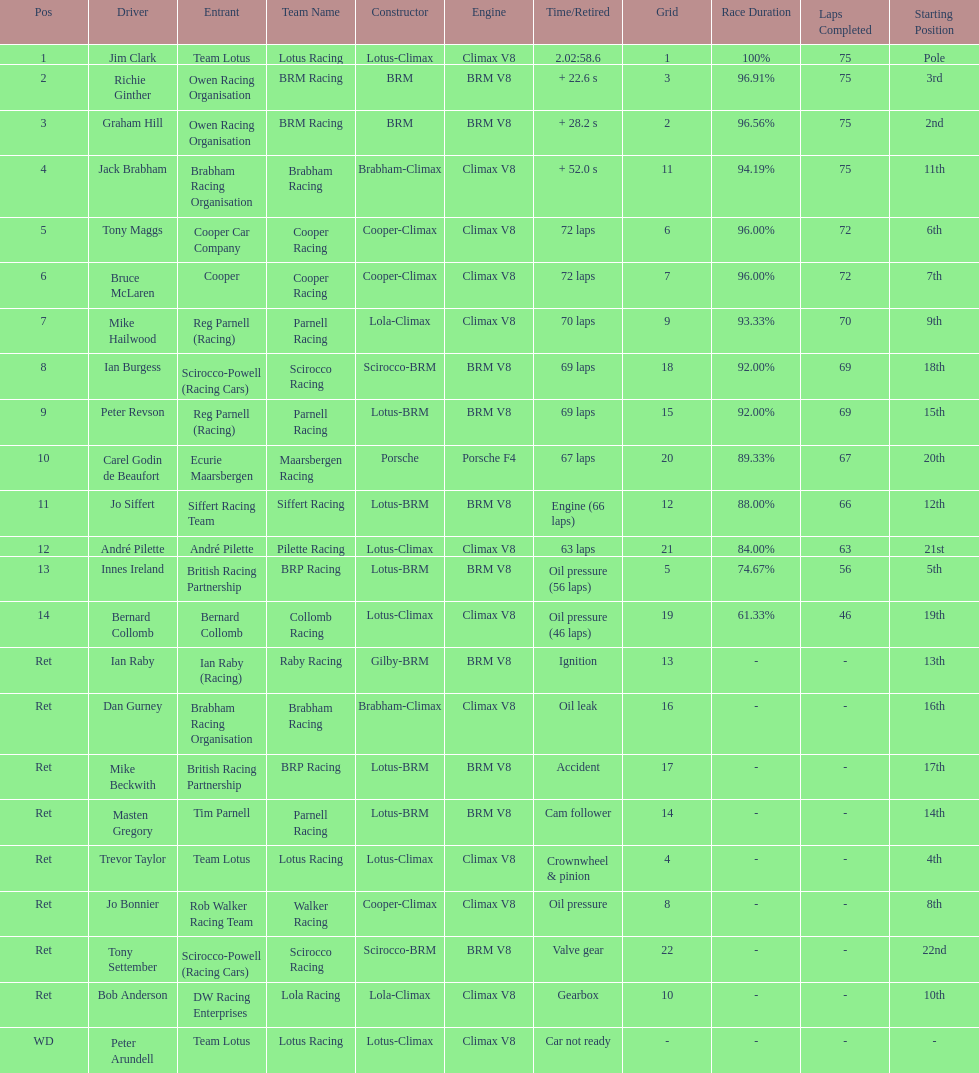Who came in earlier, tony maggs or jo siffert? Tony Maggs. 